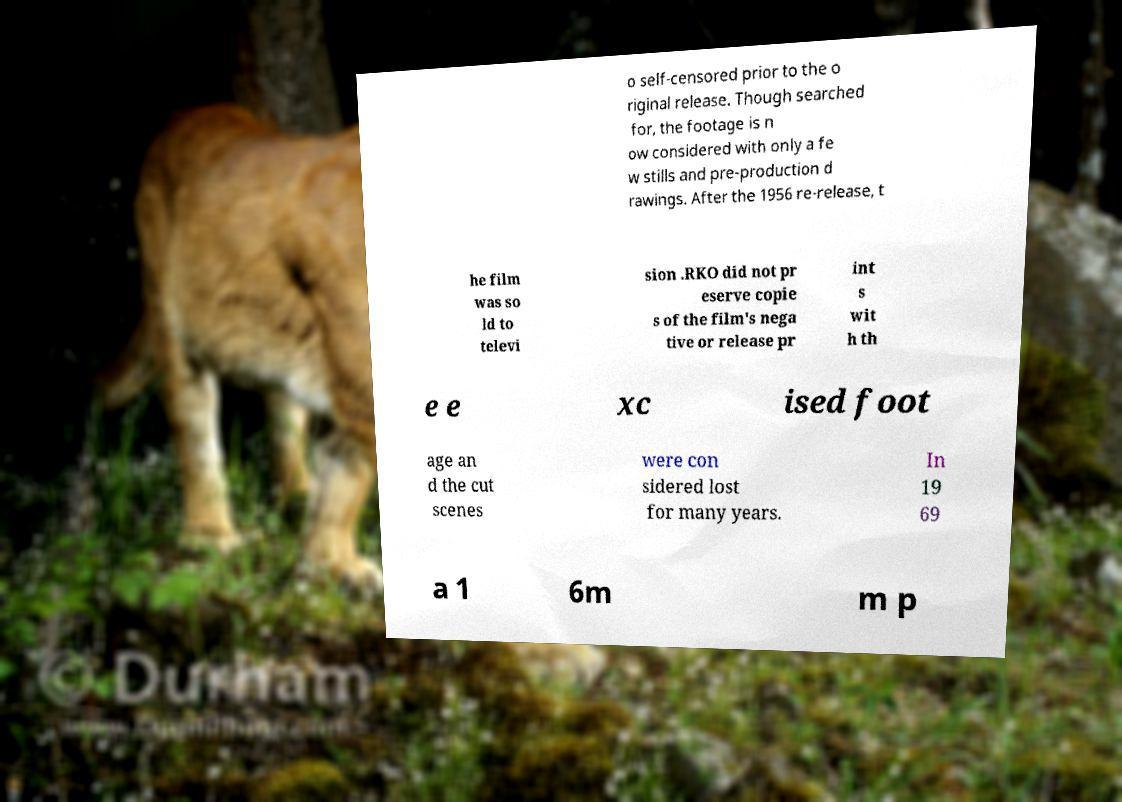Can you accurately transcribe the text from the provided image for me? o self-censored prior to the o riginal release. Though searched for, the footage is n ow considered with only a fe w stills and pre-production d rawings. After the 1956 re-release, t he film was so ld to televi sion .RKO did not pr eserve copie s of the film's nega tive or release pr int s wit h th e e xc ised foot age an d the cut scenes were con sidered lost for many years. In 19 69 a 1 6m m p 